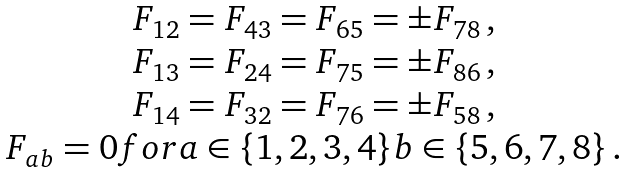Convert formula to latex. <formula><loc_0><loc_0><loc_500><loc_500>\begin{array} { c } F _ { 1 2 } = F _ { 4 3 } = F _ { 6 5 } = \pm F _ { 7 8 } \, , \\ F _ { 1 3 } = F _ { 2 4 } = F _ { 7 5 } = \pm F _ { 8 6 } \, , \\ F _ { 1 4 } = F _ { 3 2 } = F _ { 7 6 } = \pm F _ { 5 8 } \, , \\ F _ { a b } = 0 f o r { a \in \{ 1 , 2 , 3 , 4 \} } { b \in \{ 5 , 6 , 7 , 8 \} } \, . \end{array}</formula> 